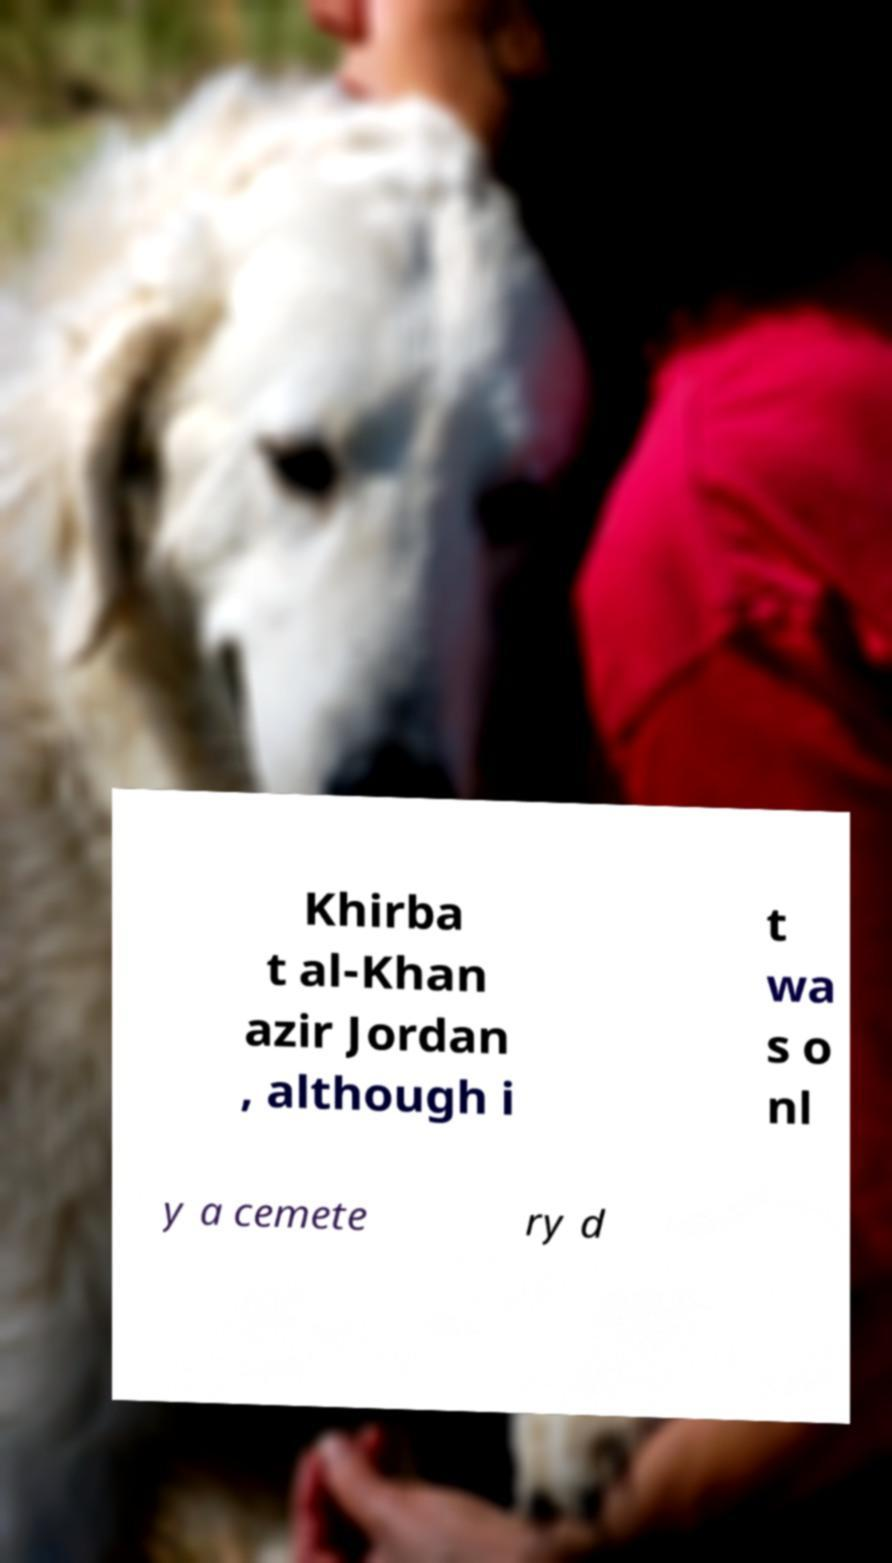Please read and relay the text visible in this image. What does it say? Khirba t al-Khan azir Jordan , although i t wa s o nl y a cemete ry d 